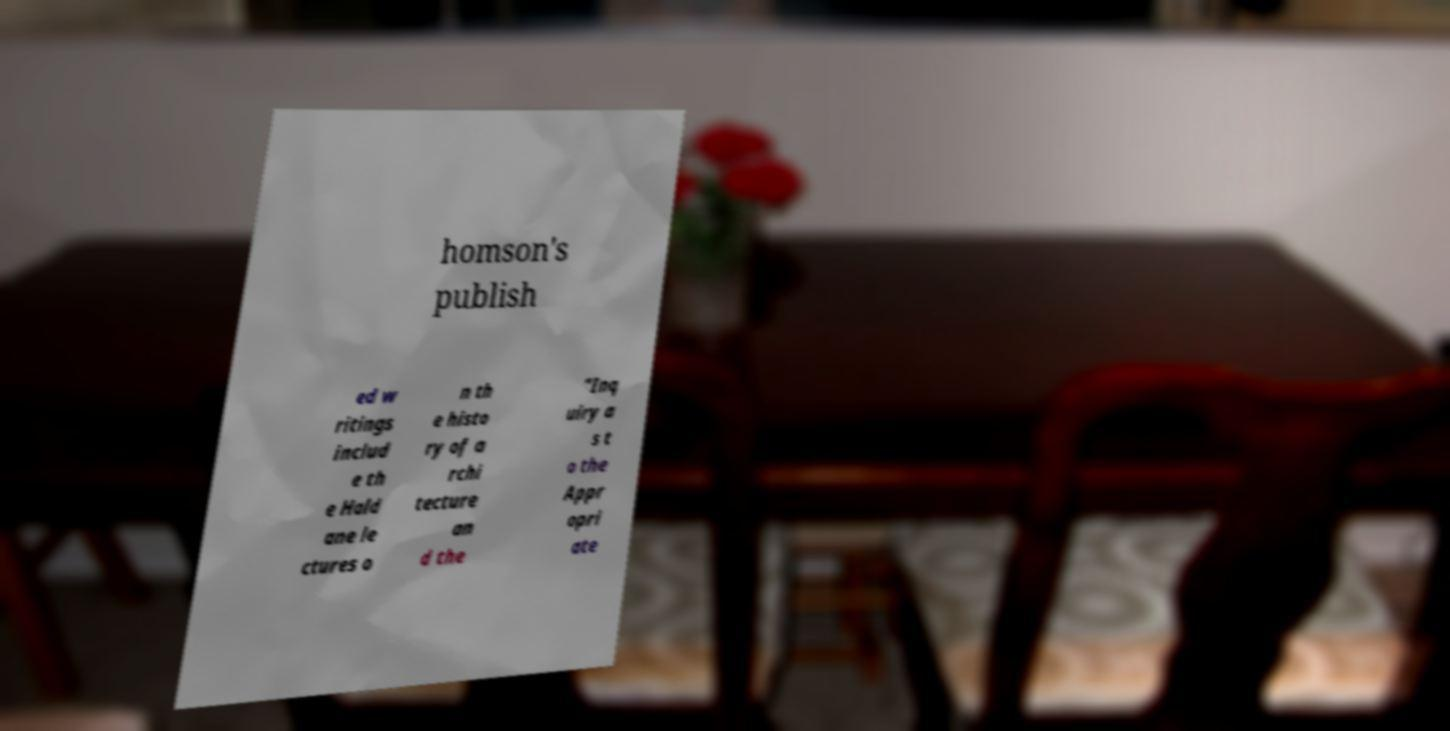Could you extract and type out the text from this image? homson's publish ed w ritings includ e th e Hald ane le ctures o n th e histo ry of a rchi tecture an d the "Inq uiry a s t o the Appr opri ate 